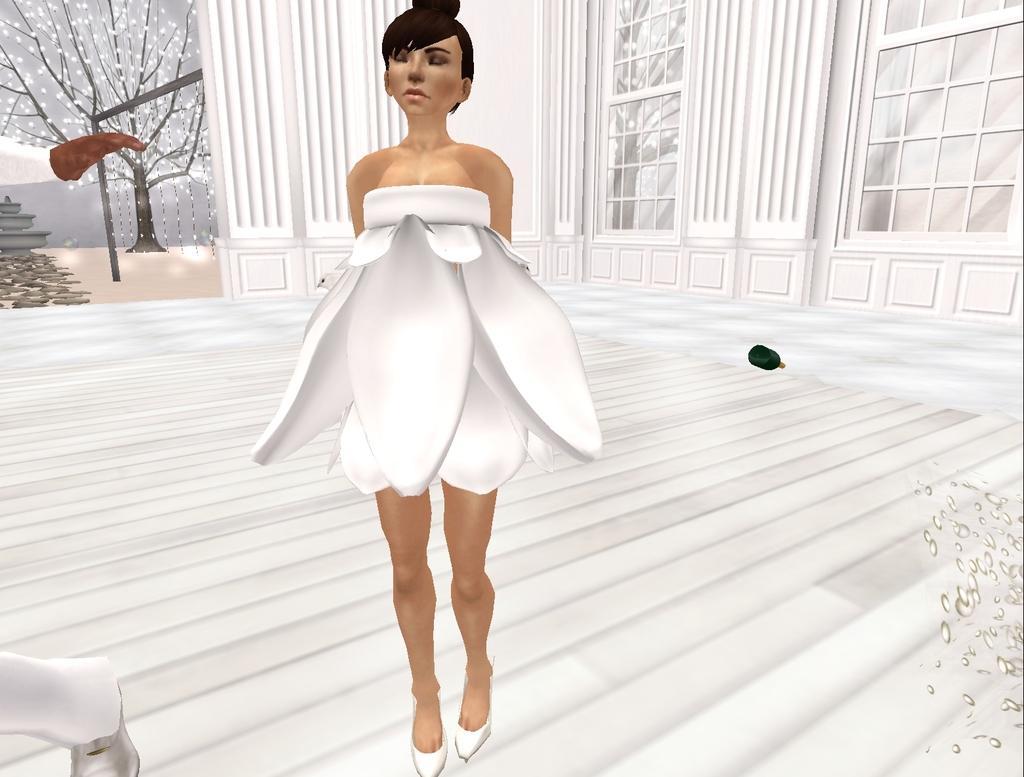Please provide a concise description of this image. It is an edited image and there is an woman with white dress on the floor. In the background windows are visible. Tree and a bottle on the floor is also present in this image. 